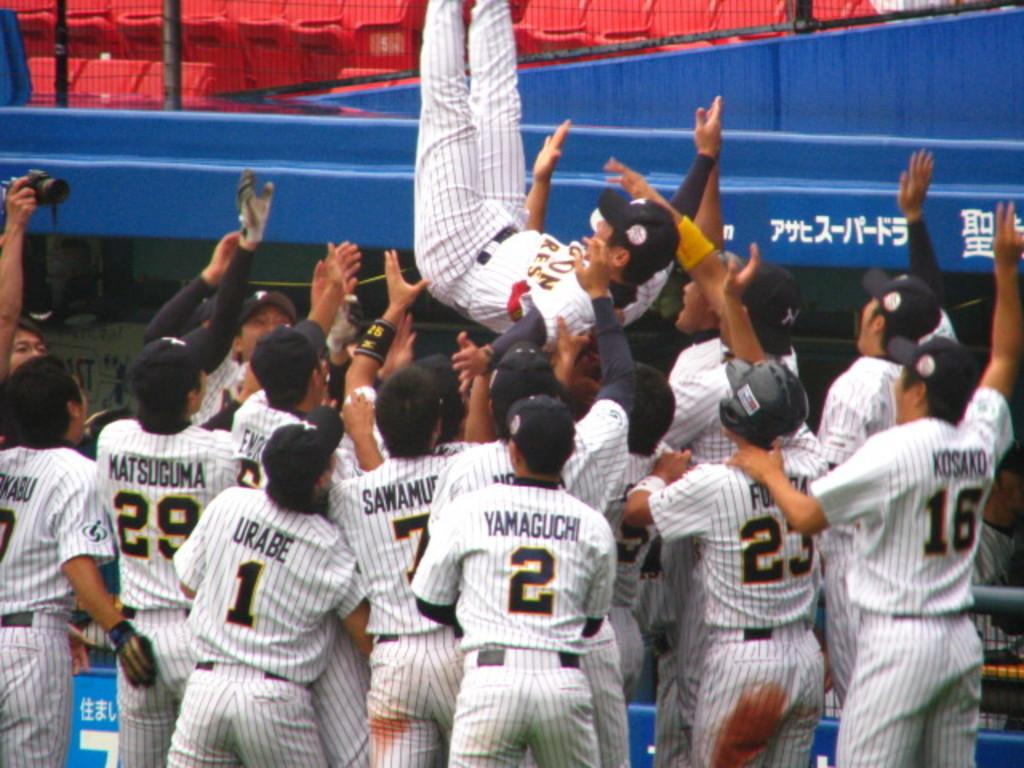<image>
Present a compact description of the photo's key features. A group of baseball players are picking up another person with one having the number 2 on his back. 